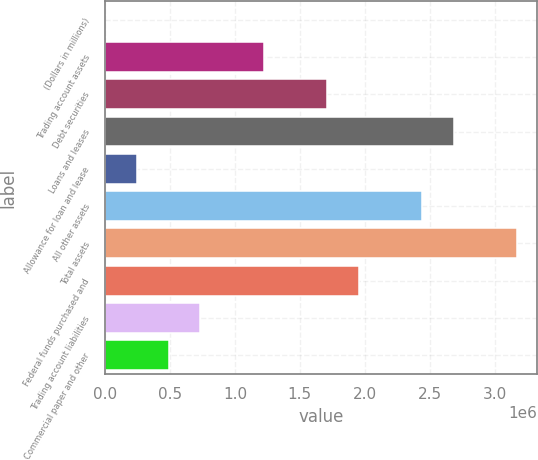Convert chart to OTSL. <chart><loc_0><loc_0><loc_500><loc_500><bar_chart><fcel>(Dollars in millions)<fcel>Trading account assets<fcel>Debt securities<fcel>Loans and leases<fcel>Allowance for loan and lease<fcel>All other assets<fcel>Total assets<fcel>Federal funds purchased and<fcel>Trading account liabilities<fcel>Commercial paper and other<nl><fcel>2010<fcel>1.22081e+06<fcel>1.70832e+06<fcel>2.68336e+06<fcel>245769<fcel>2.4396e+06<fcel>3.17088e+06<fcel>1.95208e+06<fcel>733288<fcel>489528<nl></chart> 